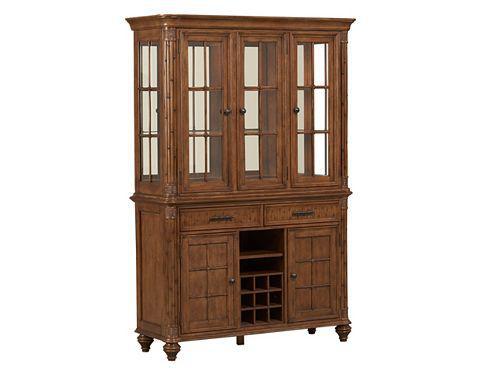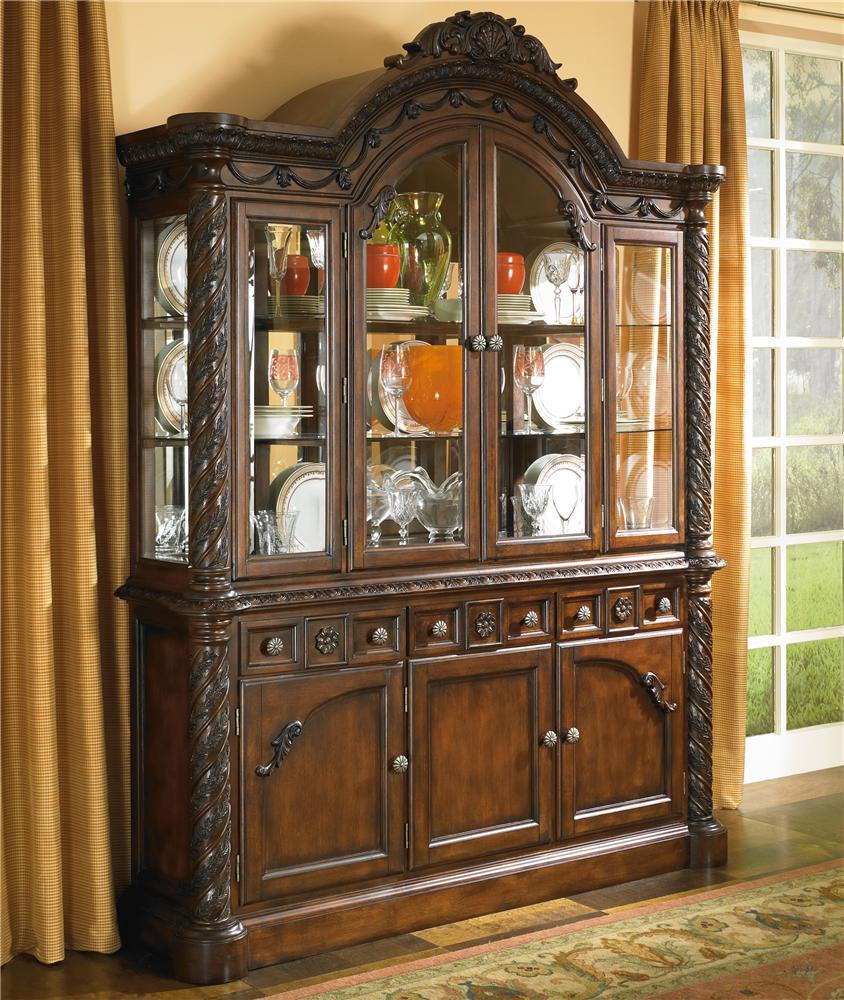The first image is the image on the left, the second image is the image on the right. Examine the images to the left and right. Is the description "There are two drawers on the cabinet in the image on the left." accurate? Answer yes or no. Yes. 